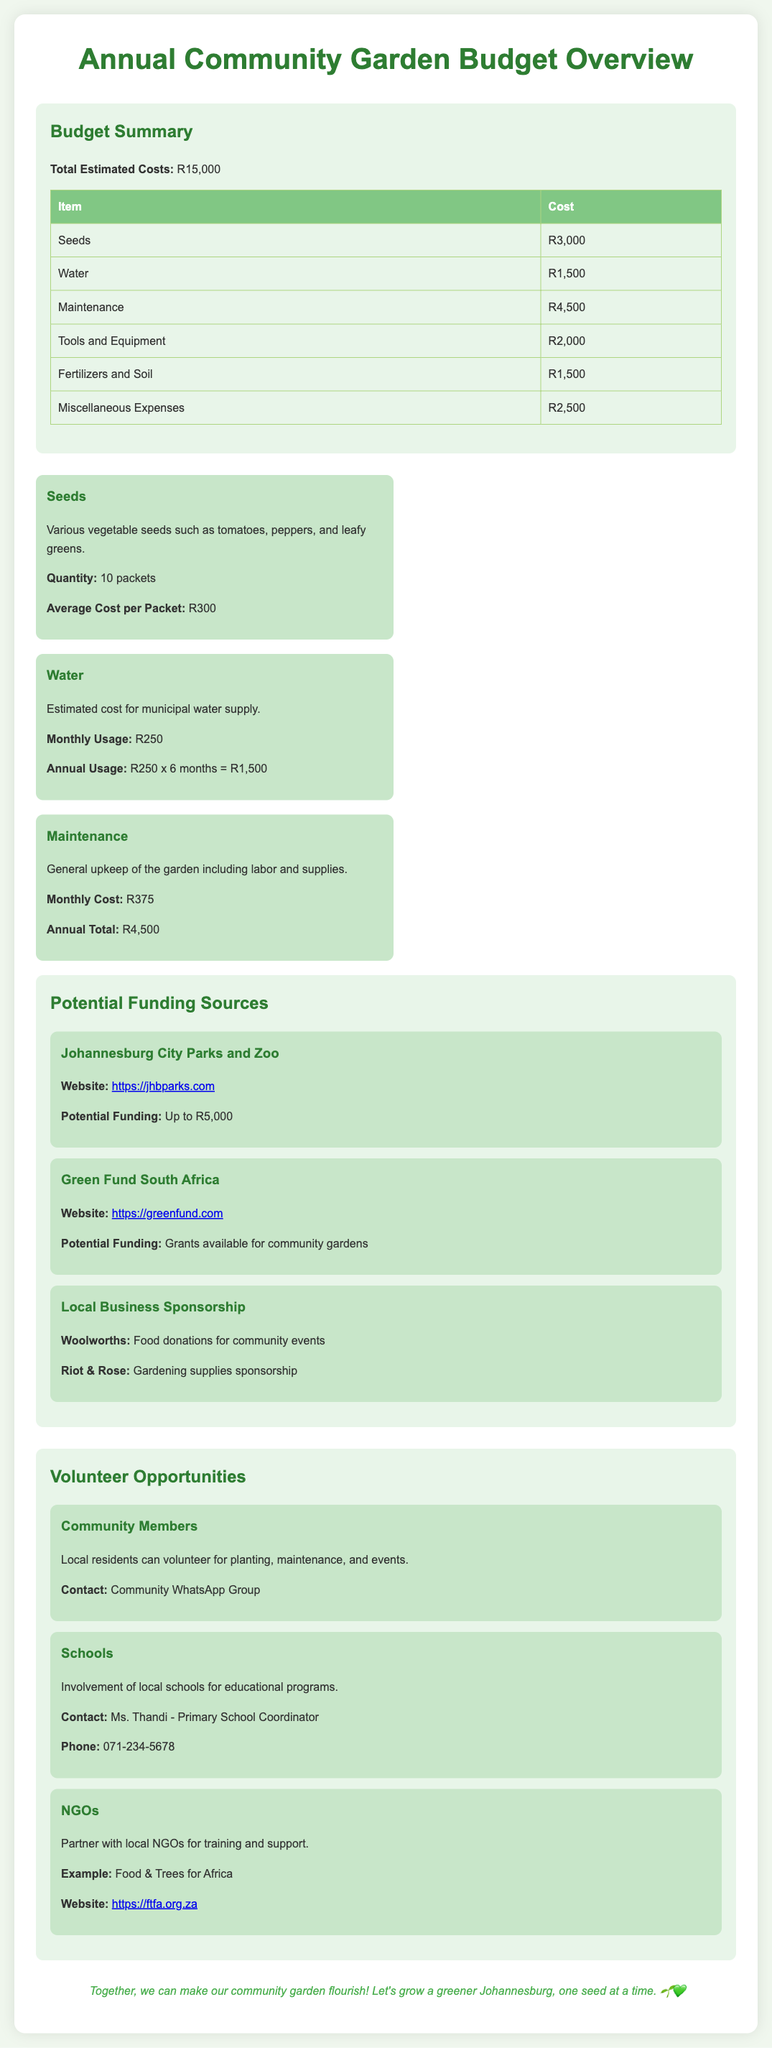what is the total estimated cost? The total estimated cost is stated in the budget summary of the document.
Answer: R15,000 how much is allocated for seeds? The amount allocated for seeds is mentioned in the budget summary table.
Answer: R3,000 what is the monthly cost of maintenance? The monthly cost of maintenance is provided under the maintenance section in the budget details.
Answer: R375 which organization offers potential funding of up to R5,000? The document lists potential funding sources, one of which offers up to R5,000.
Answer: Johannesburg City Parks and Zoo who can community members contact for volunteering? The document indicates how local residents can engage in volunteer opportunities.
Answer: Community WhatsApp Group how many packets of seeds are mentioned? The quantity of seed packets is specified in the seeds budget item.
Answer: 10 packets what is the annual water usage cost? The cost for annual water usage is calculated in the water budget item section.
Answer: R1,500 name one local business that provides sponsorship for gardening supplies. The document lists local businesses that sponsor gardening.
Answer: Riot & Rose which group is mentioned for local educational programs? The document identifies a group involved in educational programs related to gardening.
Answer: Schools 